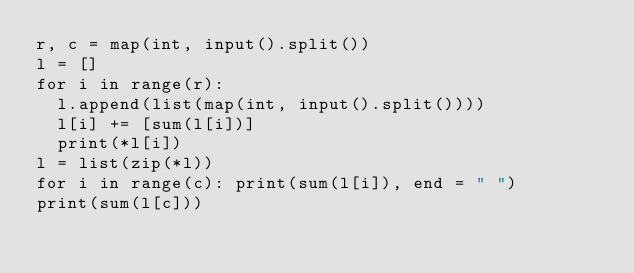Convert code to text. <code><loc_0><loc_0><loc_500><loc_500><_Python_>r, c = map(int, input().split())
l = []
for i in range(r):
  l.append(list(map(int, input().split())))
  l[i] += [sum(l[i])]
  print(*l[i])
l = list(zip(*l))
for i in range(c): print(sum(l[i]), end = " ")
print(sum(l[c]))
</code> 